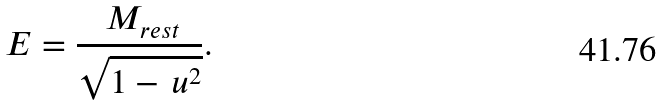<formula> <loc_0><loc_0><loc_500><loc_500>\, E = \frac { \, M _ { r e s t } } { \sqrt { 1 - \, u ^ { 2 } } } .</formula> 